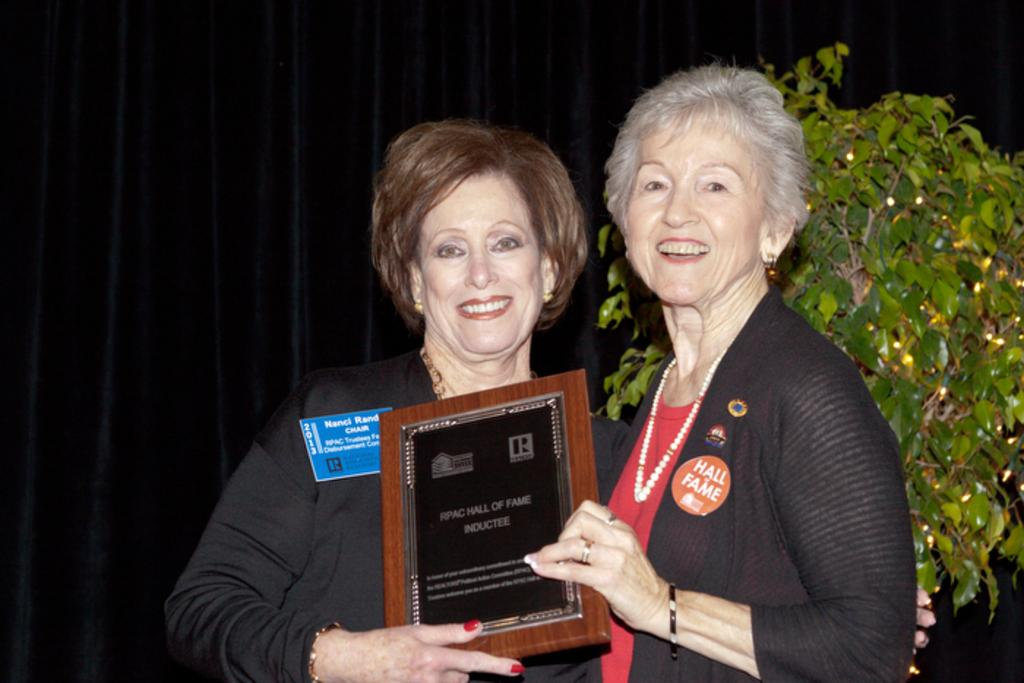How many people are in the image? There are two women in the image. What are the women doing in the image? The women are smiling and holding a frame with their hands. What can be seen in the background of the image? The background of the image is dark. What is present on the right side of the image? There is a tree on the right side of the image. What type of beetle can be seen crawling on the frame in the image? There is no beetle present in the image, and therefore no such activity can be observed. What decision did the women make before posing for the image? The provided facts do not mention any decision made by the women before posing for the image. 